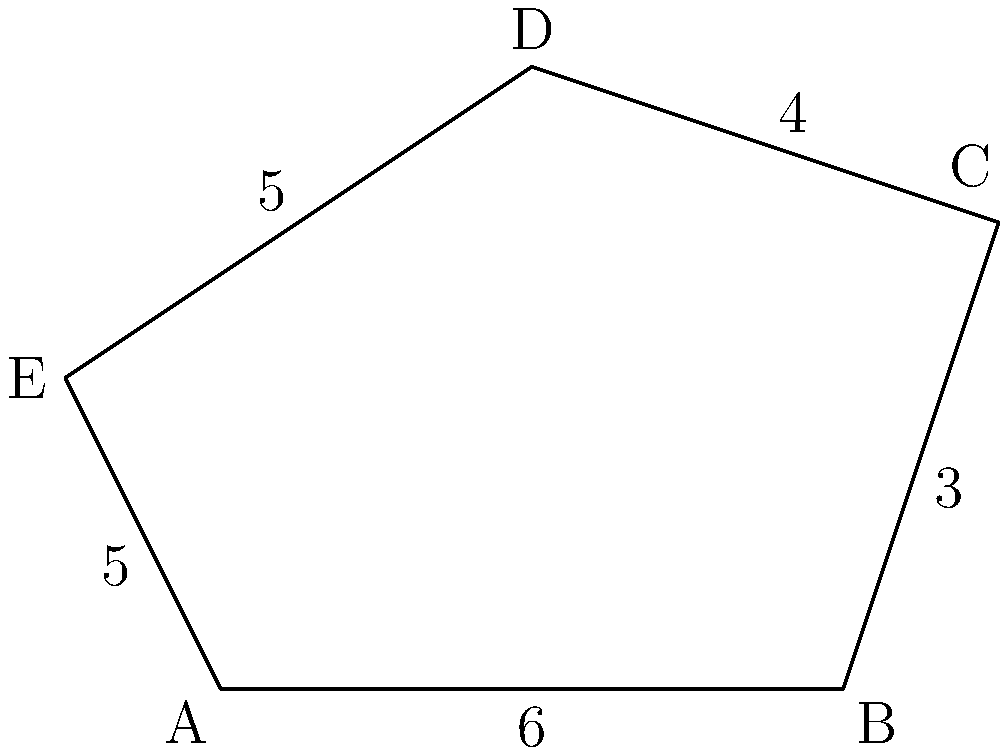As a tech support employee who enjoys breaking down concepts, explain how to find the perimeter of the irregular pentagon ABCDE shown in the diagram. All side lengths are given in centimeters. Let's break this down into simple steps:

1. Understand what perimeter means:
   - Perimeter is the total distance around the outside of a shape.

2. Identify the given information:
   - We have an irregular pentagon (5-sided shape) with all side lengths provided.

3. List out the side lengths:
   - AB = 6 cm
   - BC = 3 cm
   - CD = 4 cm
   - DE = 5 cm
   - EA = 5 cm

4. Calculate the perimeter:
   - To find the perimeter, we simply add up all the side lengths.
   - Perimeter = AB + BC + CD + DE + EA
   - Perimeter = 6 + 3 + 4 + 5 + 5
   - Perimeter = 23 cm

5. Double-check the result:
   - Ensure all sides are included and no mistakes in addition.

By following these steps, we've broken down the process of finding the perimeter into simple, manageable parts, making it easy to understand and calculate.
Answer: 23 cm 